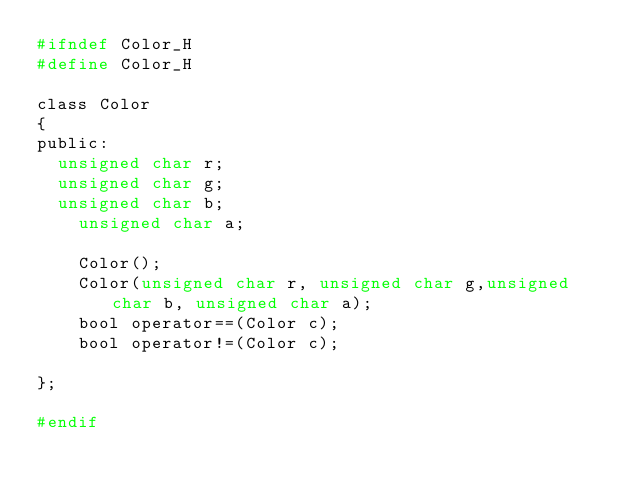Convert code to text. <code><loc_0><loc_0><loc_500><loc_500><_C_>#ifndef Color_H
#define Color_H

class Color
{
public:
	unsigned char r;
	unsigned char g;
	unsigned char b;
    unsigned char a;

    Color();
    Color(unsigned char r, unsigned char g,unsigned char b, unsigned char a);
    bool operator==(Color c);
    bool operator!=(Color c);
    
};

#endif</code> 